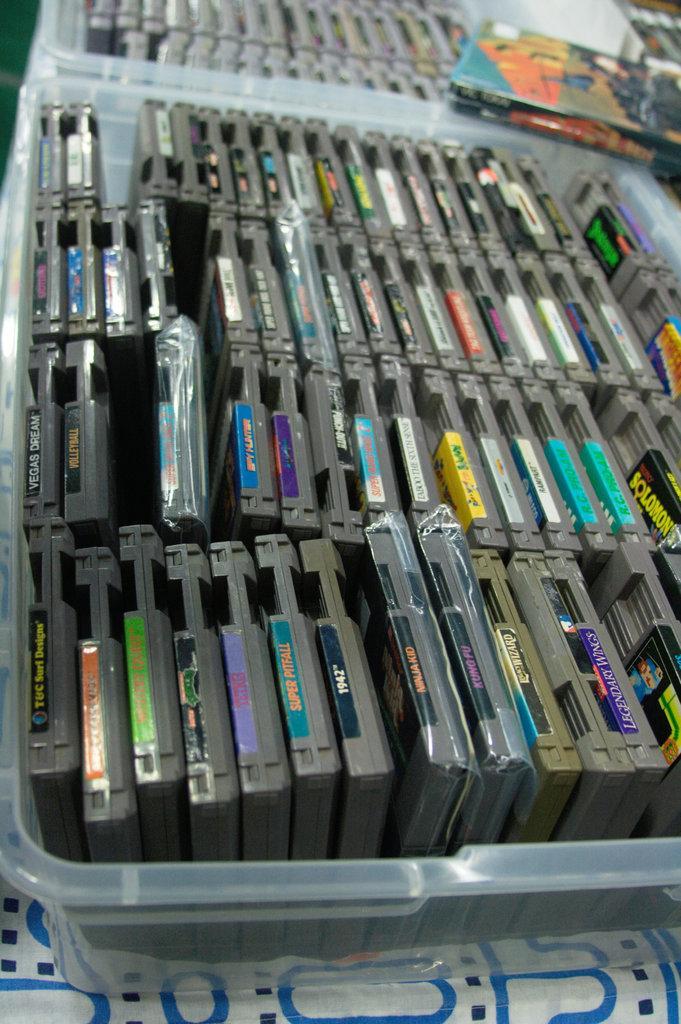How would you summarize this image in a sentence or two? The picture consists of compact disc drives in plastic boxes. At the bottom there is a table covered with cloth. 